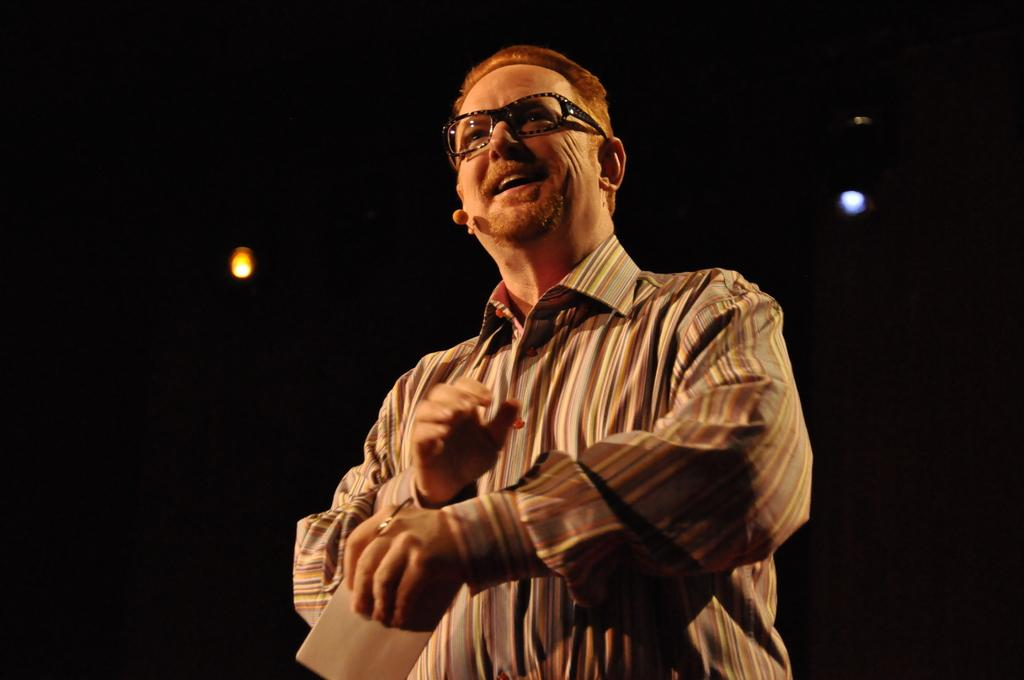What is the person in the image doing? The person is standing in the image and holding a paper. Can you describe the background of the image? There are lights visible in the background of the image. What type of yarn is the judge using to make a decision in the image? There is no judge or yarn present in the image. 